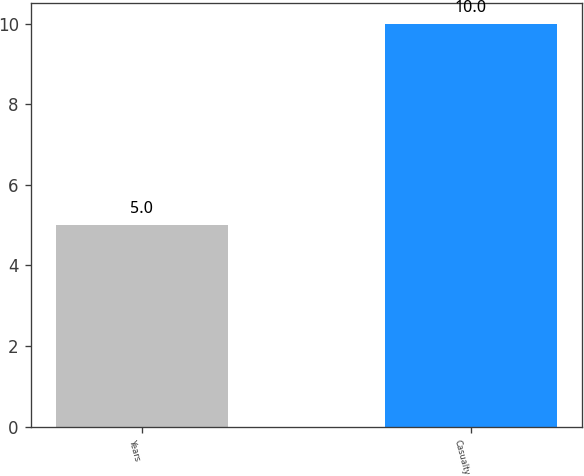<chart> <loc_0><loc_0><loc_500><loc_500><bar_chart><fcel>Years<fcel>Casualty<nl><fcel>5<fcel>10<nl></chart> 